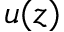<formula> <loc_0><loc_0><loc_500><loc_500>u ( z )</formula> 